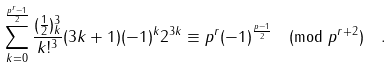<formula> <loc_0><loc_0><loc_500><loc_500>\sum _ { k = 0 } ^ { \frac { p ^ { r } - 1 } { 2 } } \frac { ( \frac { 1 } { 2 } ) _ { k } ^ { 3 } } { k ! ^ { 3 } } ( 3 k + 1 ) ( - 1 ) ^ { k } 2 ^ { 3 k } & \equiv p ^ { r } ( - 1 ) ^ { \frac { p - 1 } { 2 } } \pmod { p ^ { r + 2 } } \quad .</formula> 